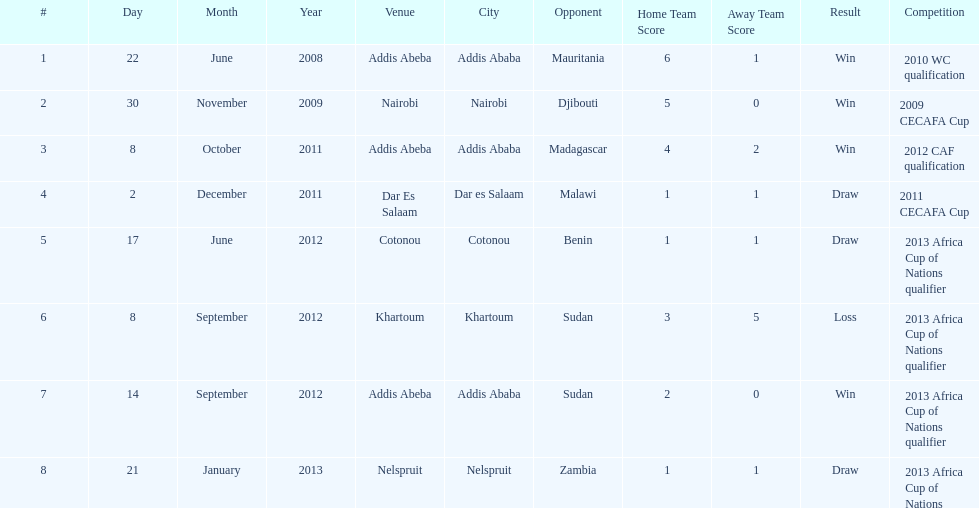What date gives was their only loss? 8 September 2012. 